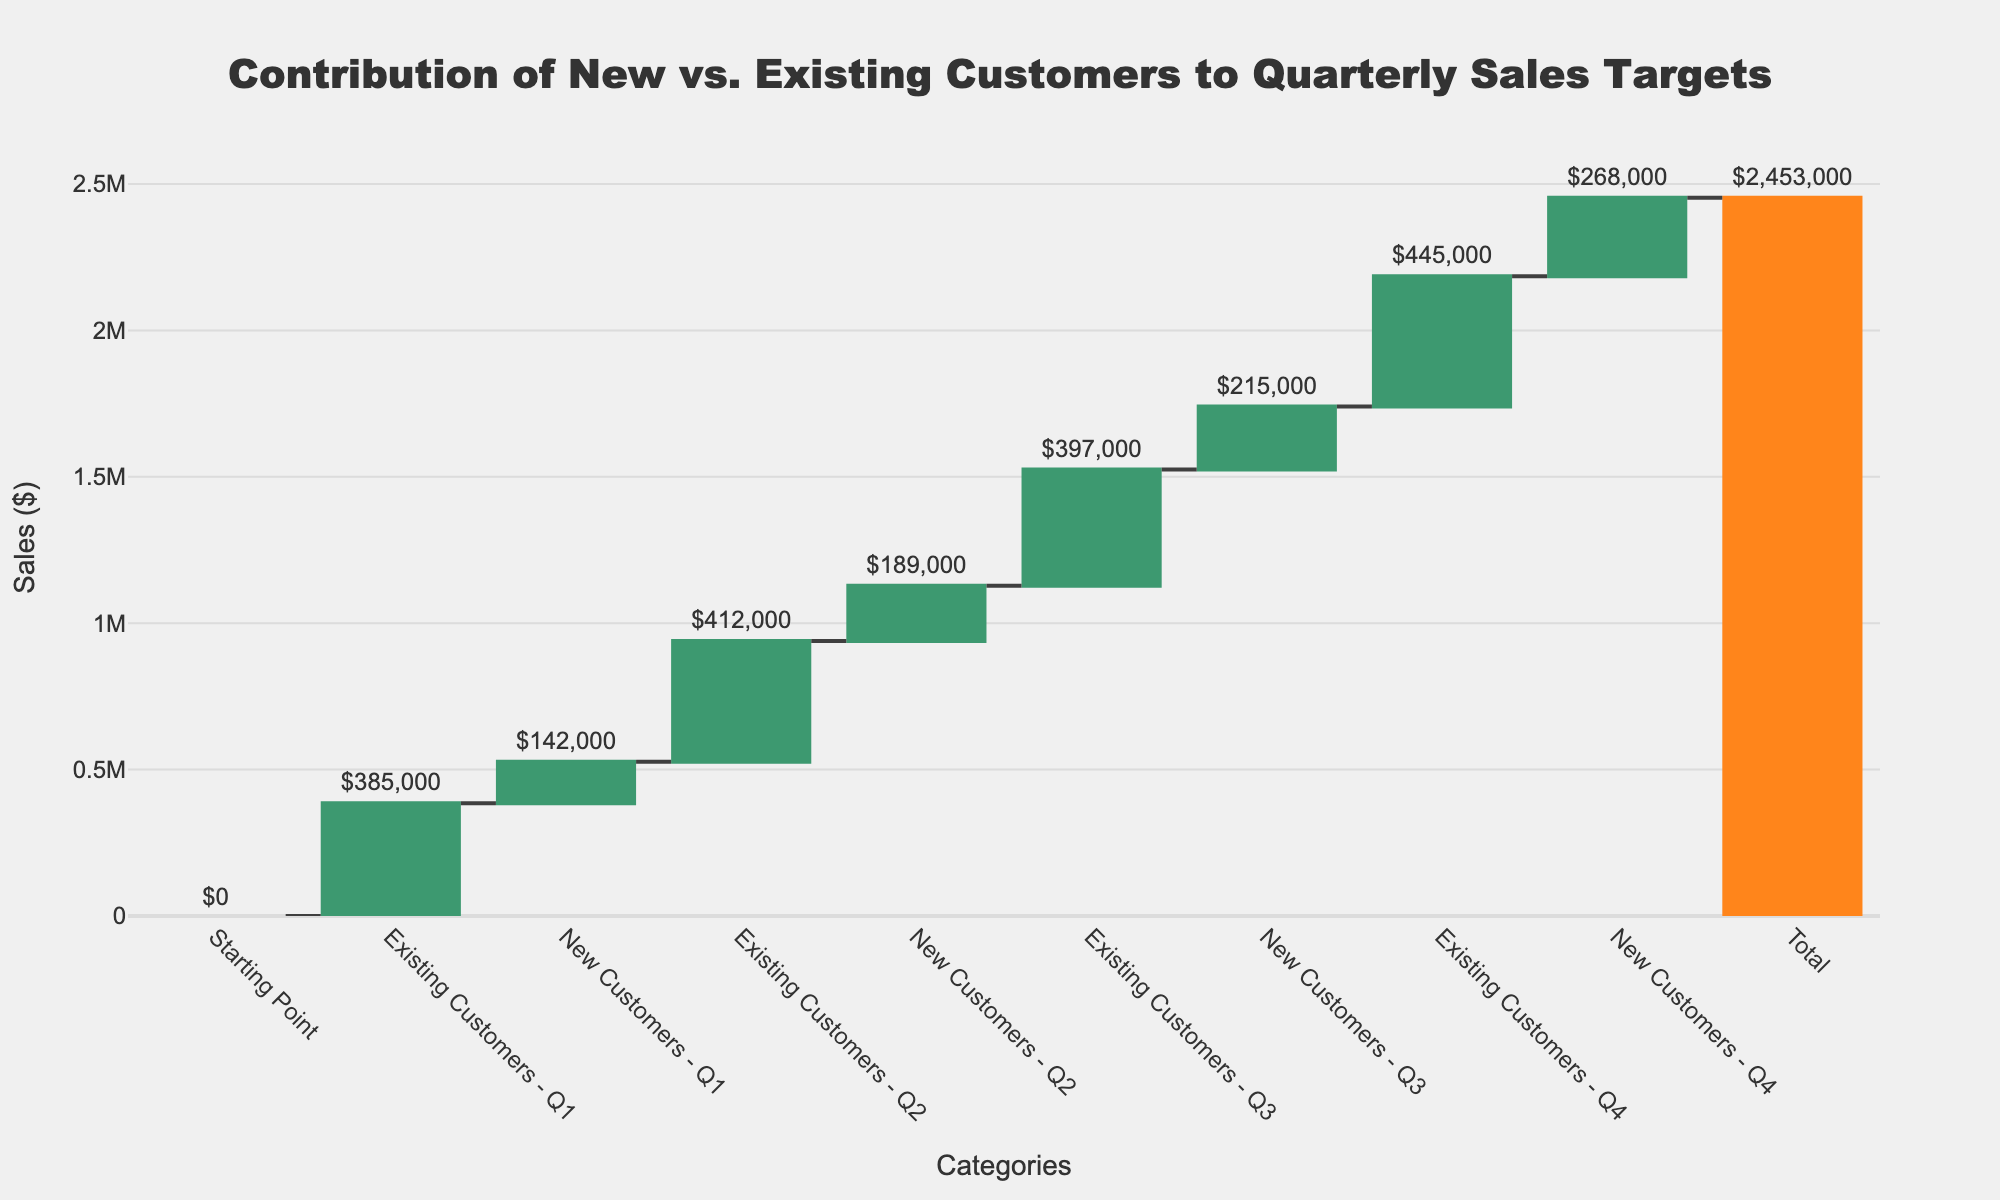What's the title of the chart? The title of the chart is typically displayed at the top. In this case, the title is written as "Contribution of New vs. Existing Customers to Quarterly Sales Targets".
Answer: Contribution of New vs. Existing Customers to Quarterly Sales Targets How many total categories are represented in the chart, including the starting point and total? Count the bars on the x-axis. There are 10 categories shown: Starting Point, Existing Customers - Q1, New Customers - Q1, Existing Customers - Q2, New Customers - Q2, Existing Customers - Q3, New Customers - Q3, Existing Customers - Q4, New Customers - Q4, and Total.
Answer: 10 Which quarter showed the highest contribution from existing customers? By looking at the heights of the bars for Existing Customers (Q1, Q2, Q3, Q4), the Existing Customers - Q4 bar is the tallest.
Answer: Q4 How much did new customers contribute in Q2? Locate the bar labeled "New Customers - Q2" and read its value, which is outside the bar. The value is $189,000.
Answer: $189,000 What is the combined contribution of new and existing customers for Q3? Sum up the values for "Existing Customers - Q3" and "New Customers - Q3". That's 397,000 (Existing) + 215,000 (New) = 612,000.
Answer: $612,000 What's the difference in sales contribution between new customers in Q1 and Q4? Subtract the value of new customers in Q1 from that in Q4. $268,000 (Q4) - $142,000 (Q1) = $126,000.
Answer: $126,000 Which category showed the overall smallest contribution? Compare the values of all the categories listed, ignoring the starting point and total. "New Customers - Q1" has the smallest contribution of $142,000.
Answer: New Customers - Q1 How did the total sales value change from the starting point to the end of Q4? The final cumulative value at the end of Q4 is $2,453,000. The starting point is 0. Thus, the total change = $2,453,000 - $0 = $2,453,000.
Answer: $2,453,000 Which category has the highest single positive change? The bar with the highest positive value outside is "New Customers - Q4" which is $268,000.
Answer: New Customers - Q4 What's the average quarterly sales contribution from existing customers? Sum all the values for existing customers: 385,000 + 412,000 + 397,000 + 445,000 = 1,639,000. Divide by 4 (the number of quarters): 1,639,000 / 4 = 409,750.
Answer: $409,750 